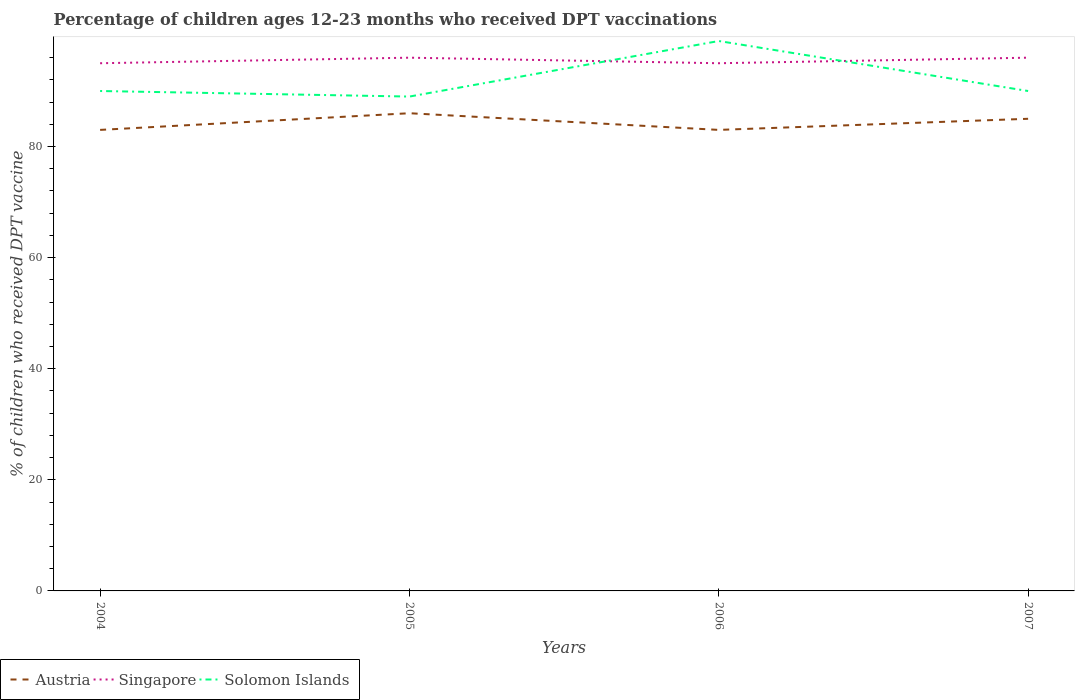How many different coloured lines are there?
Offer a terse response. 3. Is the number of lines equal to the number of legend labels?
Ensure brevity in your answer.  Yes. Across all years, what is the maximum percentage of children who received DPT vaccination in Austria?
Give a very brief answer. 83. In which year was the percentage of children who received DPT vaccination in Austria maximum?
Offer a very short reply. 2004. What is the total percentage of children who received DPT vaccination in Austria in the graph?
Give a very brief answer. 0. What is the difference between the highest and the second highest percentage of children who received DPT vaccination in Singapore?
Your answer should be very brief. 1. Is the percentage of children who received DPT vaccination in Singapore strictly greater than the percentage of children who received DPT vaccination in Solomon Islands over the years?
Provide a short and direct response. No. How many years are there in the graph?
Your answer should be compact. 4. Are the values on the major ticks of Y-axis written in scientific E-notation?
Make the answer very short. No. Does the graph contain grids?
Your answer should be very brief. No. How are the legend labels stacked?
Your answer should be compact. Horizontal. What is the title of the graph?
Make the answer very short. Percentage of children ages 12-23 months who received DPT vaccinations. Does "Rwanda" appear as one of the legend labels in the graph?
Provide a succinct answer. No. What is the label or title of the Y-axis?
Offer a terse response. % of children who received DPT vaccine. What is the % of children who received DPT vaccine in Singapore in 2005?
Ensure brevity in your answer.  96. What is the % of children who received DPT vaccine of Solomon Islands in 2005?
Your response must be concise. 89. What is the % of children who received DPT vaccine of Solomon Islands in 2006?
Ensure brevity in your answer.  99. What is the % of children who received DPT vaccine of Singapore in 2007?
Your answer should be very brief. 96. What is the % of children who received DPT vaccine of Solomon Islands in 2007?
Your response must be concise. 90. Across all years, what is the maximum % of children who received DPT vaccine of Austria?
Ensure brevity in your answer.  86. Across all years, what is the maximum % of children who received DPT vaccine in Singapore?
Ensure brevity in your answer.  96. Across all years, what is the maximum % of children who received DPT vaccine of Solomon Islands?
Make the answer very short. 99. Across all years, what is the minimum % of children who received DPT vaccine of Austria?
Provide a succinct answer. 83. Across all years, what is the minimum % of children who received DPT vaccine of Singapore?
Provide a short and direct response. 95. Across all years, what is the minimum % of children who received DPT vaccine in Solomon Islands?
Keep it short and to the point. 89. What is the total % of children who received DPT vaccine of Austria in the graph?
Offer a terse response. 337. What is the total % of children who received DPT vaccine in Singapore in the graph?
Ensure brevity in your answer.  382. What is the total % of children who received DPT vaccine in Solomon Islands in the graph?
Provide a succinct answer. 368. What is the difference between the % of children who received DPT vaccine in Singapore in 2004 and that in 2005?
Give a very brief answer. -1. What is the difference between the % of children who received DPT vaccine in Solomon Islands in 2004 and that in 2005?
Give a very brief answer. 1. What is the difference between the % of children who received DPT vaccine in Austria in 2004 and that in 2006?
Provide a short and direct response. 0. What is the difference between the % of children who received DPT vaccine of Singapore in 2004 and that in 2006?
Offer a very short reply. 0. What is the difference between the % of children who received DPT vaccine in Austria in 2004 and that in 2007?
Your answer should be compact. -2. What is the difference between the % of children who received DPT vaccine in Solomon Islands in 2004 and that in 2007?
Offer a terse response. 0. What is the difference between the % of children who received DPT vaccine in Singapore in 2005 and that in 2006?
Provide a short and direct response. 1. What is the difference between the % of children who received DPT vaccine in Solomon Islands in 2005 and that in 2006?
Provide a succinct answer. -10. What is the difference between the % of children who received DPT vaccine of Austria in 2005 and that in 2007?
Offer a terse response. 1. What is the difference between the % of children who received DPT vaccine of Singapore in 2006 and that in 2007?
Provide a short and direct response. -1. What is the difference between the % of children who received DPT vaccine of Solomon Islands in 2006 and that in 2007?
Offer a very short reply. 9. What is the difference between the % of children who received DPT vaccine in Singapore in 2004 and the % of children who received DPT vaccine in Solomon Islands in 2005?
Your answer should be very brief. 6. What is the difference between the % of children who received DPT vaccine in Austria in 2004 and the % of children who received DPT vaccine in Singapore in 2007?
Your answer should be compact. -13. What is the difference between the % of children who received DPT vaccine of Austria in 2004 and the % of children who received DPT vaccine of Solomon Islands in 2007?
Keep it short and to the point. -7. What is the difference between the % of children who received DPT vaccine in Singapore in 2004 and the % of children who received DPT vaccine in Solomon Islands in 2007?
Offer a very short reply. 5. What is the difference between the % of children who received DPT vaccine of Austria in 2005 and the % of children who received DPT vaccine of Singapore in 2006?
Offer a terse response. -9. What is the difference between the % of children who received DPT vaccine of Austria in 2005 and the % of children who received DPT vaccine of Solomon Islands in 2006?
Keep it short and to the point. -13. What is the difference between the % of children who received DPT vaccine of Singapore in 2005 and the % of children who received DPT vaccine of Solomon Islands in 2006?
Provide a short and direct response. -3. What is the difference between the % of children who received DPT vaccine of Singapore in 2005 and the % of children who received DPT vaccine of Solomon Islands in 2007?
Make the answer very short. 6. What is the difference between the % of children who received DPT vaccine in Austria in 2006 and the % of children who received DPT vaccine in Singapore in 2007?
Offer a very short reply. -13. What is the difference between the % of children who received DPT vaccine in Austria in 2006 and the % of children who received DPT vaccine in Solomon Islands in 2007?
Offer a terse response. -7. What is the difference between the % of children who received DPT vaccine of Singapore in 2006 and the % of children who received DPT vaccine of Solomon Islands in 2007?
Give a very brief answer. 5. What is the average % of children who received DPT vaccine in Austria per year?
Your answer should be very brief. 84.25. What is the average % of children who received DPT vaccine of Singapore per year?
Offer a very short reply. 95.5. What is the average % of children who received DPT vaccine of Solomon Islands per year?
Ensure brevity in your answer.  92. In the year 2004, what is the difference between the % of children who received DPT vaccine of Austria and % of children who received DPT vaccine of Solomon Islands?
Your response must be concise. -7. In the year 2004, what is the difference between the % of children who received DPT vaccine in Singapore and % of children who received DPT vaccine in Solomon Islands?
Provide a short and direct response. 5. In the year 2005, what is the difference between the % of children who received DPT vaccine of Austria and % of children who received DPT vaccine of Singapore?
Offer a very short reply. -10. In the year 2005, what is the difference between the % of children who received DPT vaccine of Austria and % of children who received DPT vaccine of Solomon Islands?
Ensure brevity in your answer.  -3. In the year 2006, what is the difference between the % of children who received DPT vaccine in Singapore and % of children who received DPT vaccine in Solomon Islands?
Your answer should be very brief. -4. In the year 2007, what is the difference between the % of children who received DPT vaccine in Singapore and % of children who received DPT vaccine in Solomon Islands?
Give a very brief answer. 6. What is the ratio of the % of children who received DPT vaccine of Austria in 2004 to that in 2005?
Provide a succinct answer. 0.97. What is the ratio of the % of children who received DPT vaccine in Solomon Islands in 2004 to that in 2005?
Your answer should be very brief. 1.01. What is the ratio of the % of children who received DPT vaccine of Austria in 2004 to that in 2006?
Offer a very short reply. 1. What is the ratio of the % of children who received DPT vaccine of Solomon Islands in 2004 to that in 2006?
Your response must be concise. 0.91. What is the ratio of the % of children who received DPT vaccine in Austria in 2004 to that in 2007?
Give a very brief answer. 0.98. What is the ratio of the % of children who received DPT vaccine in Singapore in 2004 to that in 2007?
Your answer should be compact. 0.99. What is the ratio of the % of children who received DPT vaccine of Solomon Islands in 2004 to that in 2007?
Give a very brief answer. 1. What is the ratio of the % of children who received DPT vaccine in Austria in 2005 to that in 2006?
Give a very brief answer. 1.04. What is the ratio of the % of children who received DPT vaccine in Singapore in 2005 to that in 2006?
Your answer should be very brief. 1.01. What is the ratio of the % of children who received DPT vaccine of Solomon Islands in 2005 to that in 2006?
Offer a very short reply. 0.9. What is the ratio of the % of children who received DPT vaccine in Austria in 2005 to that in 2007?
Provide a succinct answer. 1.01. What is the ratio of the % of children who received DPT vaccine of Solomon Islands in 2005 to that in 2007?
Ensure brevity in your answer.  0.99. What is the ratio of the % of children who received DPT vaccine of Austria in 2006 to that in 2007?
Provide a short and direct response. 0.98. What is the ratio of the % of children who received DPT vaccine of Singapore in 2006 to that in 2007?
Provide a short and direct response. 0.99. What is the difference between the highest and the second highest % of children who received DPT vaccine in Austria?
Make the answer very short. 1. What is the difference between the highest and the second highest % of children who received DPT vaccine in Solomon Islands?
Provide a succinct answer. 9. 